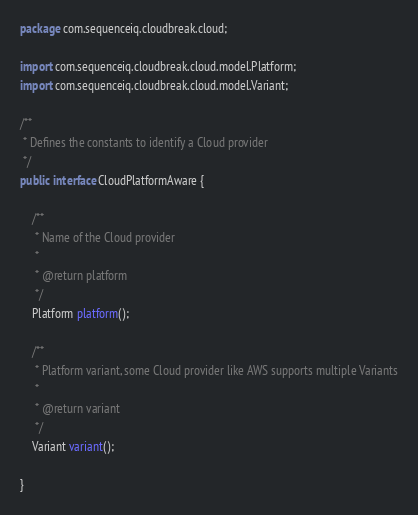<code> <loc_0><loc_0><loc_500><loc_500><_Java_>package com.sequenceiq.cloudbreak.cloud;

import com.sequenceiq.cloudbreak.cloud.model.Platform;
import com.sequenceiq.cloudbreak.cloud.model.Variant;

/**
 * Defines the constants to identify a Cloud provider
 */
public interface CloudPlatformAware {

    /**
     * Name of the Cloud provider
     *
     * @return platform
     */
    Platform platform();

    /**
     * Platform variant, some Cloud provider like AWS supports multiple Variants
     *
     * @return variant
     */
    Variant variant();

}
</code> 